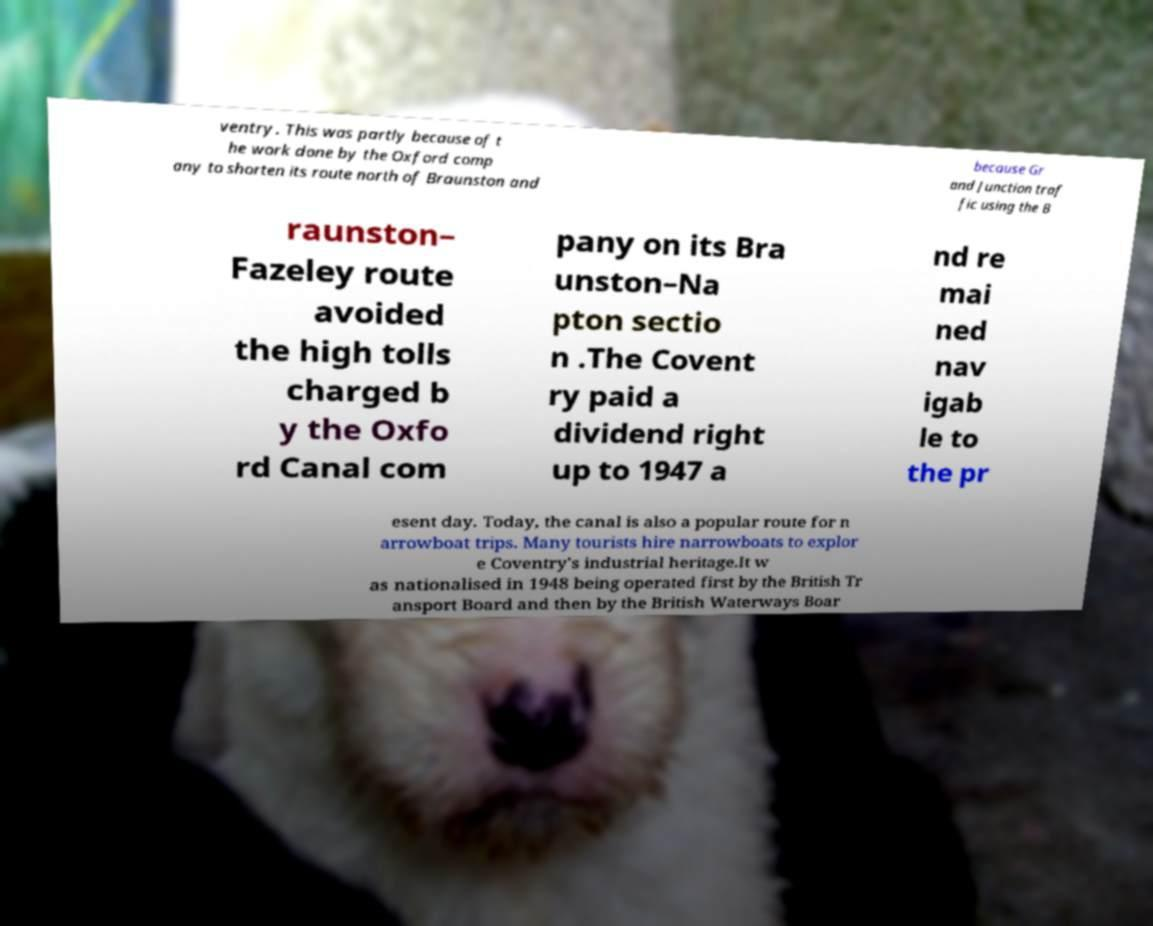Please identify and transcribe the text found in this image. ventry. This was partly because of t he work done by the Oxford comp any to shorten its route north of Braunston and because Gr and Junction traf fic using the B raunston– Fazeley route avoided the high tolls charged b y the Oxfo rd Canal com pany on its Bra unston–Na pton sectio n .The Covent ry paid a dividend right up to 1947 a nd re mai ned nav igab le to the pr esent day. Today, the canal is also a popular route for n arrowboat trips. Many tourists hire narrowboats to explor e Coventry's industrial heritage.It w as nationalised in 1948 being operated first by the British Tr ansport Board and then by the British Waterways Boar 